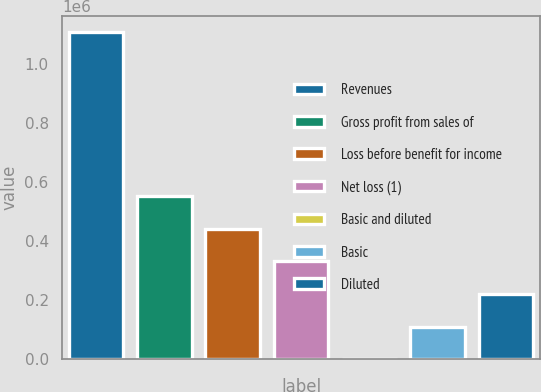Convert chart. <chart><loc_0><loc_0><loc_500><loc_500><bar_chart><fcel>Revenues<fcel>Gross profit from sales of<fcel>Loss before benefit for income<fcel>Net loss (1)<fcel>Basic and diluted<fcel>Basic<fcel>Diluted<nl><fcel>1.10654e+06<fcel>553270<fcel>442616<fcel>331962<fcel>0.56<fcel>110654<fcel>221308<nl></chart> 